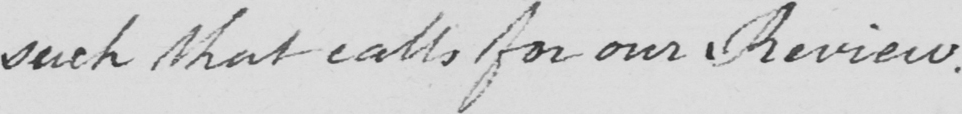Please provide the text content of this handwritten line. such that calls for our Review . 